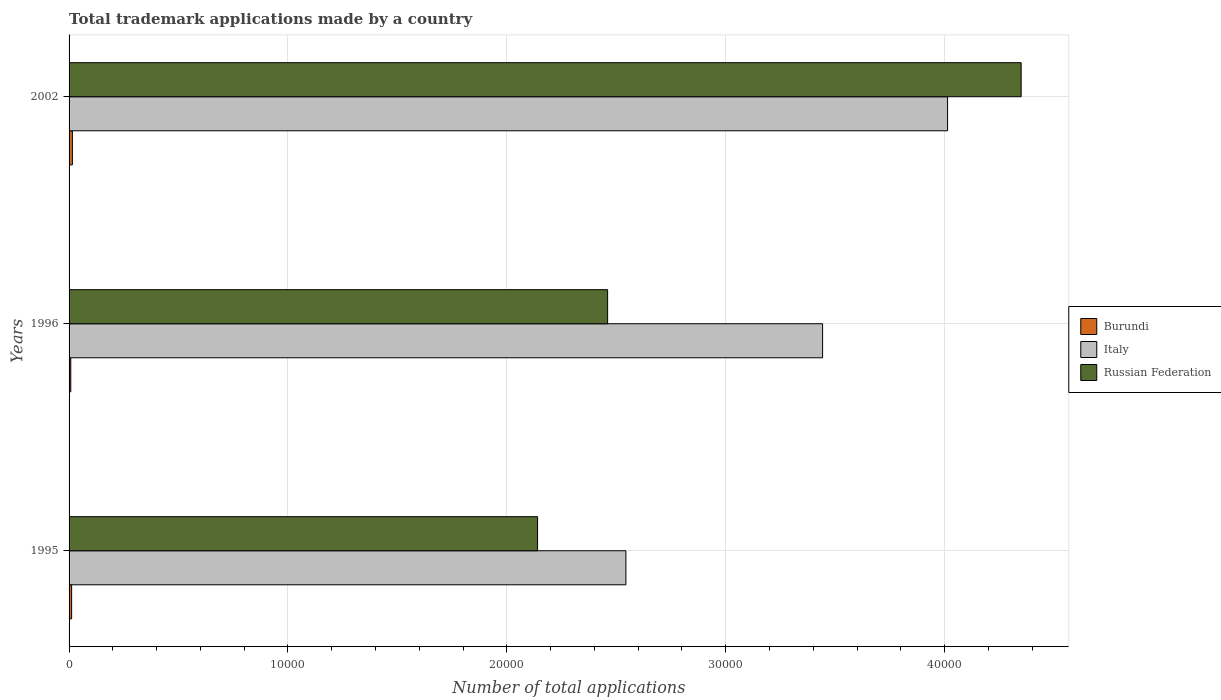Are the number of bars per tick equal to the number of legend labels?
Offer a terse response. Yes. How many bars are there on the 2nd tick from the top?
Your answer should be compact. 3. In how many cases, is the number of bars for a given year not equal to the number of legend labels?
Your response must be concise. 0. What is the number of applications made by in Italy in 1995?
Provide a succinct answer. 2.54e+04. Across all years, what is the maximum number of applications made by in Burundi?
Your answer should be compact. 152. Across all years, what is the minimum number of applications made by in Russian Federation?
Ensure brevity in your answer.  2.14e+04. In which year was the number of applications made by in Russian Federation minimum?
Ensure brevity in your answer.  1995. What is the total number of applications made by in Russian Federation in the graph?
Give a very brief answer. 8.95e+04. What is the difference between the number of applications made by in Burundi in 1995 and that in 2002?
Make the answer very short. -35. What is the difference between the number of applications made by in Burundi in 1996 and the number of applications made by in Russian Federation in 2002?
Offer a terse response. -4.34e+04. What is the average number of applications made by in Russian Federation per year?
Ensure brevity in your answer.  2.98e+04. In the year 1996, what is the difference between the number of applications made by in Russian Federation and number of applications made by in Burundi?
Offer a terse response. 2.45e+04. In how many years, is the number of applications made by in Burundi greater than 16000 ?
Your answer should be compact. 0. What is the ratio of the number of applications made by in Russian Federation in 1995 to that in 1996?
Your answer should be compact. 0.87. Is the number of applications made by in Burundi in 1995 less than that in 1996?
Give a very brief answer. No. Is the difference between the number of applications made by in Russian Federation in 1996 and 2002 greater than the difference between the number of applications made by in Burundi in 1996 and 2002?
Give a very brief answer. No. What is the difference between the highest and the second highest number of applications made by in Russian Federation?
Your answer should be compact. 1.89e+04. What is the difference between the highest and the lowest number of applications made by in Italy?
Offer a very short reply. 1.47e+04. What does the 1st bar from the top in 1995 represents?
Keep it short and to the point. Russian Federation. What does the 2nd bar from the bottom in 2002 represents?
Provide a succinct answer. Italy. Are the values on the major ticks of X-axis written in scientific E-notation?
Provide a short and direct response. No. Does the graph contain any zero values?
Keep it short and to the point. No. Does the graph contain grids?
Your response must be concise. Yes. Where does the legend appear in the graph?
Keep it short and to the point. Center right. How are the legend labels stacked?
Your answer should be compact. Vertical. What is the title of the graph?
Offer a terse response. Total trademark applications made by a country. What is the label or title of the X-axis?
Your response must be concise. Number of total applications. What is the label or title of the Y-axis?
Make the answer very short. Years. What is the Number of total applications of Burundi in 1995?
Give a very brief answer. 117. What is the Number of total applications in Italy in 1995?
Give a very brief answer. 2.54e+04. What is the Number of total applications in Russian Federation in 1995?
Give a very brief answer. 2.14e+04. What is the Number of total applications in Italy in 1996?
Your answer should be compact. 3.44e+04. What is the Number of total applications of Russian Federation in 1996?
Provide a short and direct response. 2.46e+04. What is the Number of total applications in Burundi in 2002?
Keep it short and to the point. 152. What is the Number of total applications of Italy in 2002?
Make the answer very short. 4.01e+04. What is the Number of total applications in Russian Federation in 2002?
Your response must be concise. 4.35e+04. Across all years, what is the maximum Number of total applications in Burundi?
Your answer should be compact. 152. Across all years, what is the maximum Number of total applications of Italy?
Offer a very short reply. 4.01e+04. Across all years, what is the maximum Number of total applications of Russian Federation?
Give a very brief answer. 4.35e+04. Across all years, what is the minimum Number of total applications in Burundi?
Your answer should be very brief. 78. Across all years, what is the minimum Number of total applications in Italy?
Your response must be concise. 2.54e+04. Across all years, what is the minimum Number of total applications of Russian Federation?
Provide a short and direct response. 2.14e+04. What is the total Number of total applications in Burundi in the graph?
Offer a very short reply. 347. What is the total Number of total applications in Italy in the graph?
Offer a very short reply. 1.00e+05. What is the total Number of total applications in Russian Federation in the graph?
Ensure brevity in your answer.  8.95e+04. What is the difference between the Number of total applications in Burundi in 1995 and that in 1996?
Your answer should be very brief. 39. What is the difference between the Number of total applications of Italy in 1995 and that in 1996?
Your answer should be compact. -8985. What is the difference between the Number of total applications of Russian Federation in 1995 and that in 1996?
Your response must be concise. -3200. What is the difference between the Number of total applications of Burundi in 1995 and that in 2002?
Keep it short and to the point. -35. What is the difference between the Number of total applications in Italy in 1995 and that in 2002?
Your response must be concise. -1.47e+04. What is the difference between the Number of total applications of Russian Federation in 1995 and that in 2002?
Offer a terse response. -2.21e+04. What is the difference between the Number of total applications in Burundi in 1996 and that in 2002?
Make the answer very short. -74. What is the difference between the Number of total applications in Italy in 1996 and that in 2002?
Your response must be concise. -5710. What is the difference between the Number of total applications of Russian Federation in 1996 and that in 2002?
Your answer should be very brief. -1.89e+04. What is the difference between the Number of total applications in Burundi in 1995 and the Number of total applications in Italy in 1996?
Offer a very short reply. -3.43e+04. What is the difference between the Number of total applications in Burundi in 1995 and the Number of total applications in Russian Federation in 1996?
Make the answer very short. -2.45e+04. What is the difference between the Number of total applications in Italy in 1995 and the Number of total applications in Russian Federation in 1996?
Provide a short and direct response. 835. What is the difference between the Number of total applications in Burundi in 1995 and the Number of total applications in Italy in 2002?
Keep it short and to the point. -4.00e+04. What is the difference between the Number of total applications of Burundi in 1995 and the Number of total applications of Russian Federation in 2002?
Offer a terse response. -4.34e+04. What is the difference between the Number of total applications in Italy in 1995 and the Number of total applications in Russian Federation in 2002?
Provide a short and direct response. -1.81e+04. What is the difference between the Number of total applications of Burundi in 1996 and the Number of total applications of Italy in 2002?
Your answer should be very brief. -4.01e+04. What is the difference between the Number of total applications in Burundi in 1996 and the Number of total applications in Russian Federation in 2002?
Offer a terse response. -4.34e+04. What is the difference between the Number of total applications of Italy in 1996 and the Number of total applications of Russian Federation in 2002?
Make the answer very short. -9071. What is the average Number of total applications of Burundi per year?
Provide a short and direct response. 115.67. What is the average Number of total applications in Italy per year?
Keep it short and to the point. 3.33e+04. What is the average Number of total applications of Russian Federation per year?
Ensure brevity in your answer.  2.98e+04. In the year 1995, what is the difference between the Number of total applications in Burundi and Number of total applications in Italy?
Your response must be concise. -2.53e+04. In the year 1995, what is the difference between the Number of total applications of Burundi and Number of total applications of Russian Federation?
Offer a terse response. -2.13e+04. In the year 1995, what is the difference between the Number of total applications in Italy and Number of total applications in Russian Federation?
Provide a short and direct response. 4035. In the year 1996, what is the difference between the Number of total applications of Burundi and Number of total applications of Italy?
Provide a short and direct response. -3.43e+04. In the year 1996, what is the difference between the Number of total applications of Burundi and Number of total applications of Russian Federation?
Make the answer very short. -2.45e+04. In the year 1996, what is the difference between the Number of total applications in Italy and Number of total applications in Russian Federation?
Keep it short and to the point. 9820. In the year 2002, what is the difference between the Number of total applications of Burundi and Number of total applications of Italy?
Provide a short and direct response. -4.00e+04. In the year 2002, what is the difference between the Number of total applications of Burundi and Number of total applications of Russian Federation?
Your answer should be compact. -4.33e+04. In the year 2002, what is the difference between the Number of total applications in Italy and Number of total applications in Russian Federation?
Ensure brevity in your answer.  -3361. What is the ratio of the Number of total applications in Burundi in 1995 to that in 1996?
Offer a very short reply. 1.5. What is the ratio of the Number of total applications in Italy in 1995 to that in 1996?
Keep it short and to the point. 0.74. What is the ratio of the Number of total applications of Russian Federation in 1995 to that in 1996?
Give a very brief answer. 0.87. What is the ratio of the Number of total applications in Burundi in 1995 to that in 2002?
Offer a terse response. 0.77. What is the ratio of the Number of total applications in Italy in 1995 to that in 2002?
Offer a terse response. 0.63. What is the ratio of the Number of total applications of Russian Federation in 1995 to that in 2002?
Keep it short and to the point. 0.49. What is the ratio of the Number of total applications of Burundi in 1996 to that in 2002?
Provide a short and direct response. 0.51. What is the ratio of the Number of total applications of Italy in 1996 to that in 2002?
Offer a terse response. 0.86. What is the ratio of the Number of total applications of Russian Federation in 1996 to that in 2002?
Your answer should be very brief. 0.57. What is the difference between the highest and the second highest Number of total applications in Italy?
Your answer should be very brief. 5710. What is the difference between the highest and the second highest Number of total applications in Russian Federation?
Keep it short and to the point. 1.89e+04. What is the difference between the highest and the lowest Number of total applications of Burundi?
Offer a terse response. 74. What is the difference between the highest and the lowest Number of total applications of Italy?
Your response must be concise. 1.47e+04. What is the difference between the highest and the lowest Number of total applications of Russian Federation?
Provide a short and direct response. 2.21e+04. 